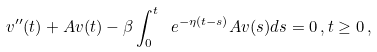Convert formula to latex. <formula><loc_0><loc_0><loc_500><loc_500>v ^ { \prime \prime } ( t ) + A v ( t ) - \beta \int _ { 0 } ^ { t } \ e ^ { - \eta ( t - s ) } A v ( s ) d s = 0 \, , t \geq 0 \, ,</formula> 